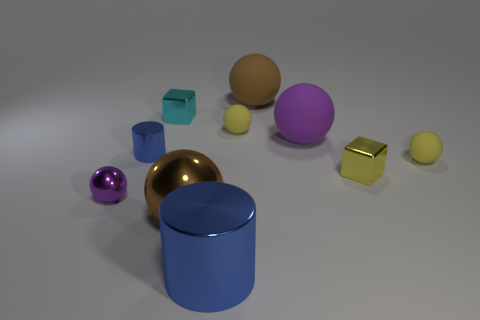There is another ball that is the same color as the large metallic sphere; what is its size?
Ensure brevity in your answer.  Large. Are there the same number of tiny metallic things to the right of the small purple metallic sphere and purple rubber objects?
Your response must be concise. No. How many small blue things are the same shape as the small purple shiny thing?
Your response must be concise. 0. There is a yellow sphere behind the tiny yellow matte object that is on the right side of the small shiny object right of the big metal sphere; how big is it?
Give a very brief answer. Small. Does the brown sphere behind the small purple metal object have the same material as the large blue cylinder?
Your answer should be very brief. No. Is the number of brown balls that are right of the big metal ball the same as the number of matte things behind the tiny cyan shiny thing?
Your response must be concise. Yes. What is the material of the large purple object that is the same shape as the big brown shiny thing?
Give a very brief answer. Rubber. Is there a large metal thing that is right of the small yellow ball that is behind the purple sphere behind the small purple ball?
Provide a succinct answer. No. Does the brown thing left of the large cylinder have the same shape as the big brown matte thing behind the cyan metallic object?
Offer a very short reply. Yes. Is the number of large brown matte spheres that are left of the small purple metal thing greater than the number of objects?
Keep it short and to the point. No. 